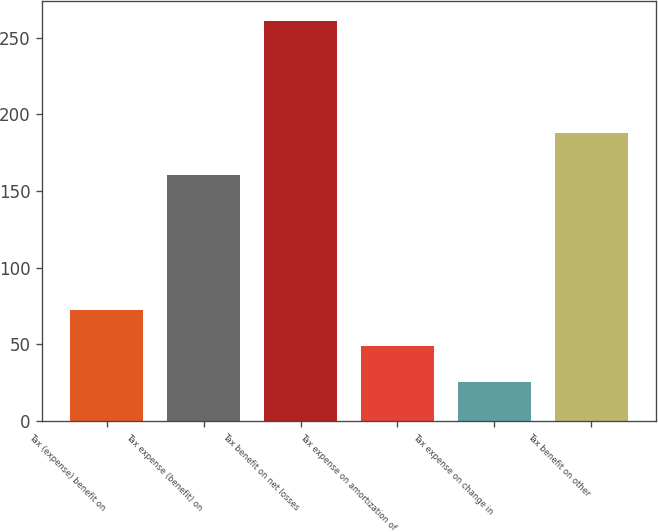<chart> <loc_0><loc_0><loc_500><loc_500><bar_chart><fcel>Tax (expense) benefit on<fcel>Tax expense (benefit) on<fcel>Tax benefit on net losses<fcel>Tax expense on amortization of<fcel>Tax expense on change in<fcel>Tax benefit on other<nl><fcel>72.2<fcel>160.6<fcel>261<fcel>48.6<fcel>25<fcel>188<nl></chart> 